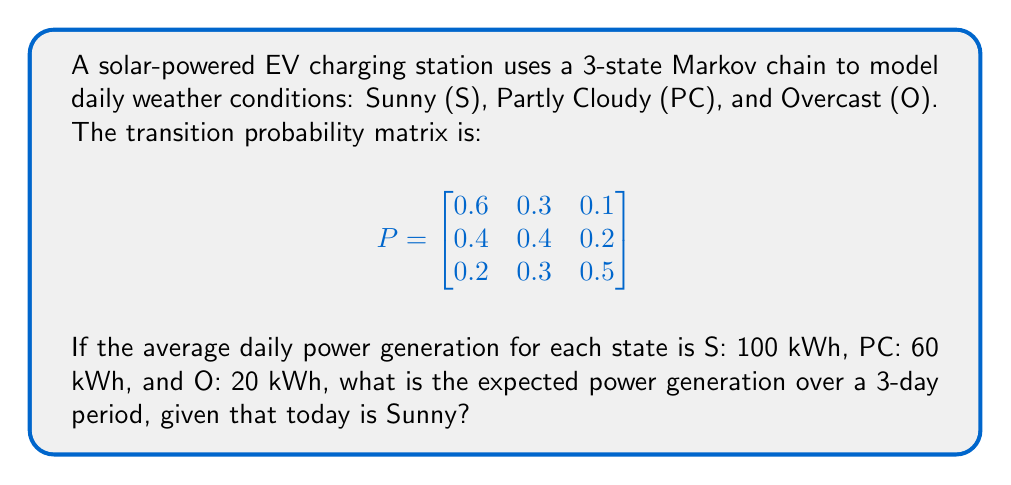Can you solve this math problem? To solve this problem, we'll follow these steps:

1) First, we need to calculate the probabilities of being in each state after 1, 2, and 3 days, given that we start in the Sunny state.

2) Let $\pi_0 = [1, 0, 0]$ be the initial state vector (Sunny).

3) For day 1: $\pi_1 = \pi_0 P = [0.6, 0.3, 0.1]$

4) For day 2: $\pi_2 = \pi_1 P = [0.48, 0.33, 0.19]$

5) For day 3: $\pi_3 = \pi_2 P = [0.426, 0.339, 0.235]$

6) Now, we calculate the expected power generation for each day:

   Day 1: $E_1 = 100 \cdot 0.6 + 60 \cdot 0.3 + 20 \cdot 0.1 = 78$ kWh
   Day 2: $E_2 = 100 \cdot 0.48 + 60 \cdot 0.33 + 20 \cdot 0.19 = 67.8$ kWh
   Day 3: $E_3 = 100 \cdot 0.426 + 60 \cdot 0.339 + 20 \cdot 0.235 = 62.34$ kWh

7) The total expected power generation over 3 days is the sum of these values:

   $E_{total} = E_1 + E_2 + E_3 = 78 + 67.8 + 62.34 = 208.14$ kWh
Answer: 208.14 kWh 